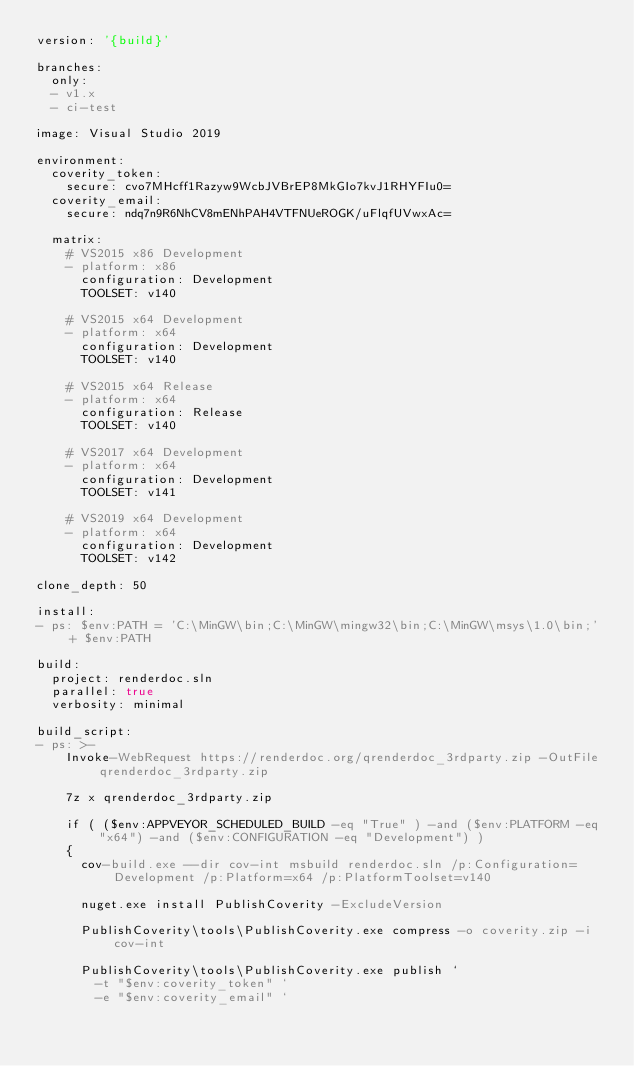<code> <loc_0><loc_0><loc_500><loc_500><_YAML_>version: '{build}'

branches:
  only:
  - v1.x
  - ci-test

image: Visual Studio 2019

environment:
  coverity_token:
    secure: cvo7MHcff1Razyw9WcbJVBrEP8MkGIo7kvJ1RHYFIu0=
  coverity_email:
    secure: ndq7n9R6NhCV8mENhPAH4VTFNUeROGK/uFlqfUVwxAc=

  matrix:
    # VS2015 x86 Development
    - platform: x86
      configuration: Development
      TOOLSET: v140

    # VS2015 x64 Development
    - platform: x64
      configuration: Development
      TOOLSET: v140

    # VS2015 x64 Release
    - platform: x64
      configuration: Release
      TOOLSET: v140

    # VS2017 x64 Development
    - platform: x64
      configuration: Development
      TOOLSET: v141

    # VS2019 x64 Development
    - platform: x64
      configuration: Development
      TOOLSET: v142

clone_depth: 50

install:
- ps: $env:PATH = 'C:\MinGW\bin;C:\MinGW\mingw32\bin;C:\MinGW\msys\1.0\bin;' + $env:PATH

build:
  project: renderdoc.sln
  parallel: true
  verbosity: minimal

build_script:
- ps: >-
    Invoke-WebRequest https://renderdoc.org/qrenderdoc_3rdparty.zip -OutFile qrenderdoc_3rdparty.zip

    7z x qrenderdoc_3rdparty.zip

    if ( ($env:APPVEYOR_SCHEDULED_BUILD -eq "True" ) -and ($env:PLATFORM -eq "x64") -and ($env:CONFIGURATION -eq "Development") )
    {
      cov-build.exe --dir cov-int msbuild renderdoc.sln /p:Configuration=Development /p:Platform=x64 /p:PlatformToolset=v140

      nuget.exe install PublishCoverity -ExcludeVersion

      PublishCoverity\tools\PublishCoverity.exe compress -o coverity.zip -i cov-int

      PublishCoverity\tools\PublishCoverity.exe publish `
        -t "$env:coverity_token" `
        -e "$env:coverity_email" `</code> 